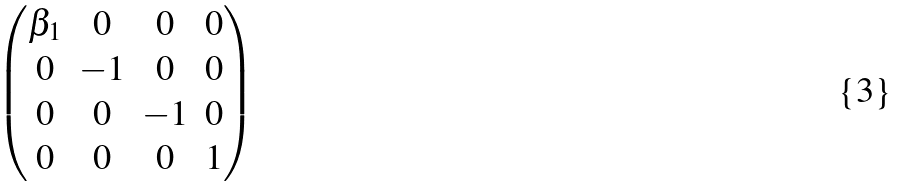<formula> <loc_0><loc_0><loc_500><loc_500>\begin{pmatrix} \beta _ { 1 } & 0 & 0 & 0 \\ 0 & - 1 & 0 & 0 \\ 0 & 0 & - 1 & 0 \\ 0 & 0 & 0 & 1 \end{pmatrix}</formula> 